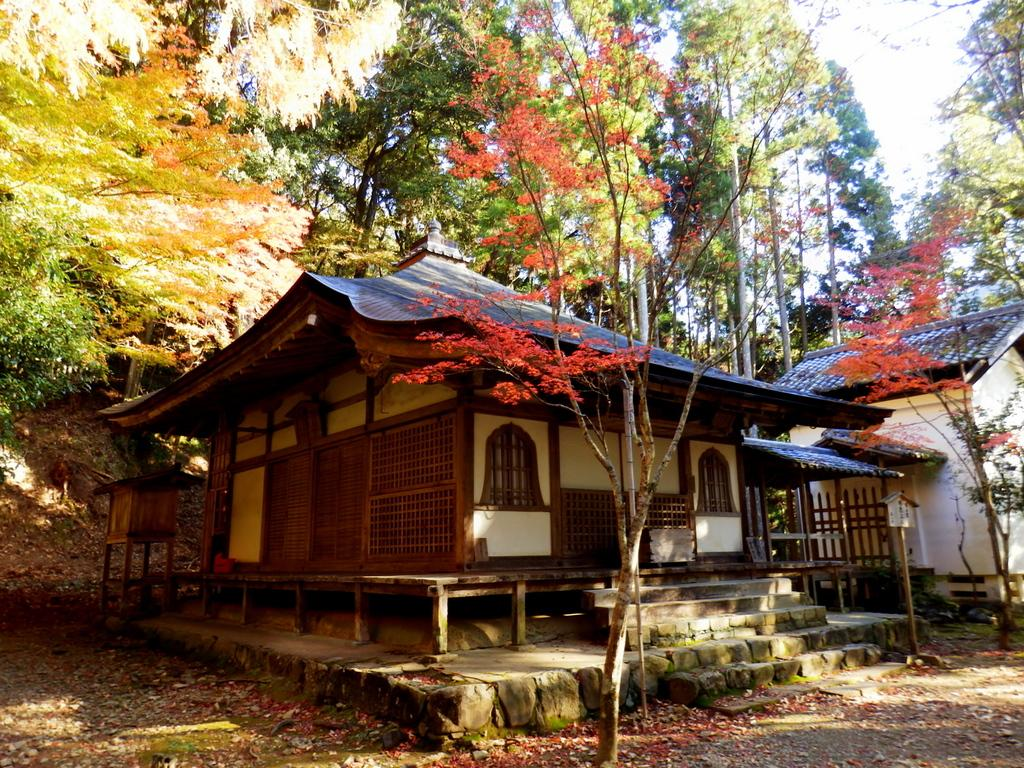What can be seen in the front of the image? There are trees and houses in the front of the image. What else is present in the front of the image besides trees and houses? There are objects in the front of the image. What can be seen in the background of the image? There are trees and the sky visible in the background of the image. How many boys are playing with the dogs in the image? There are no boys or dogs present in the image. What color are the legs of the trees in the background? Trees do not have legs, so this question cannot be answered. 